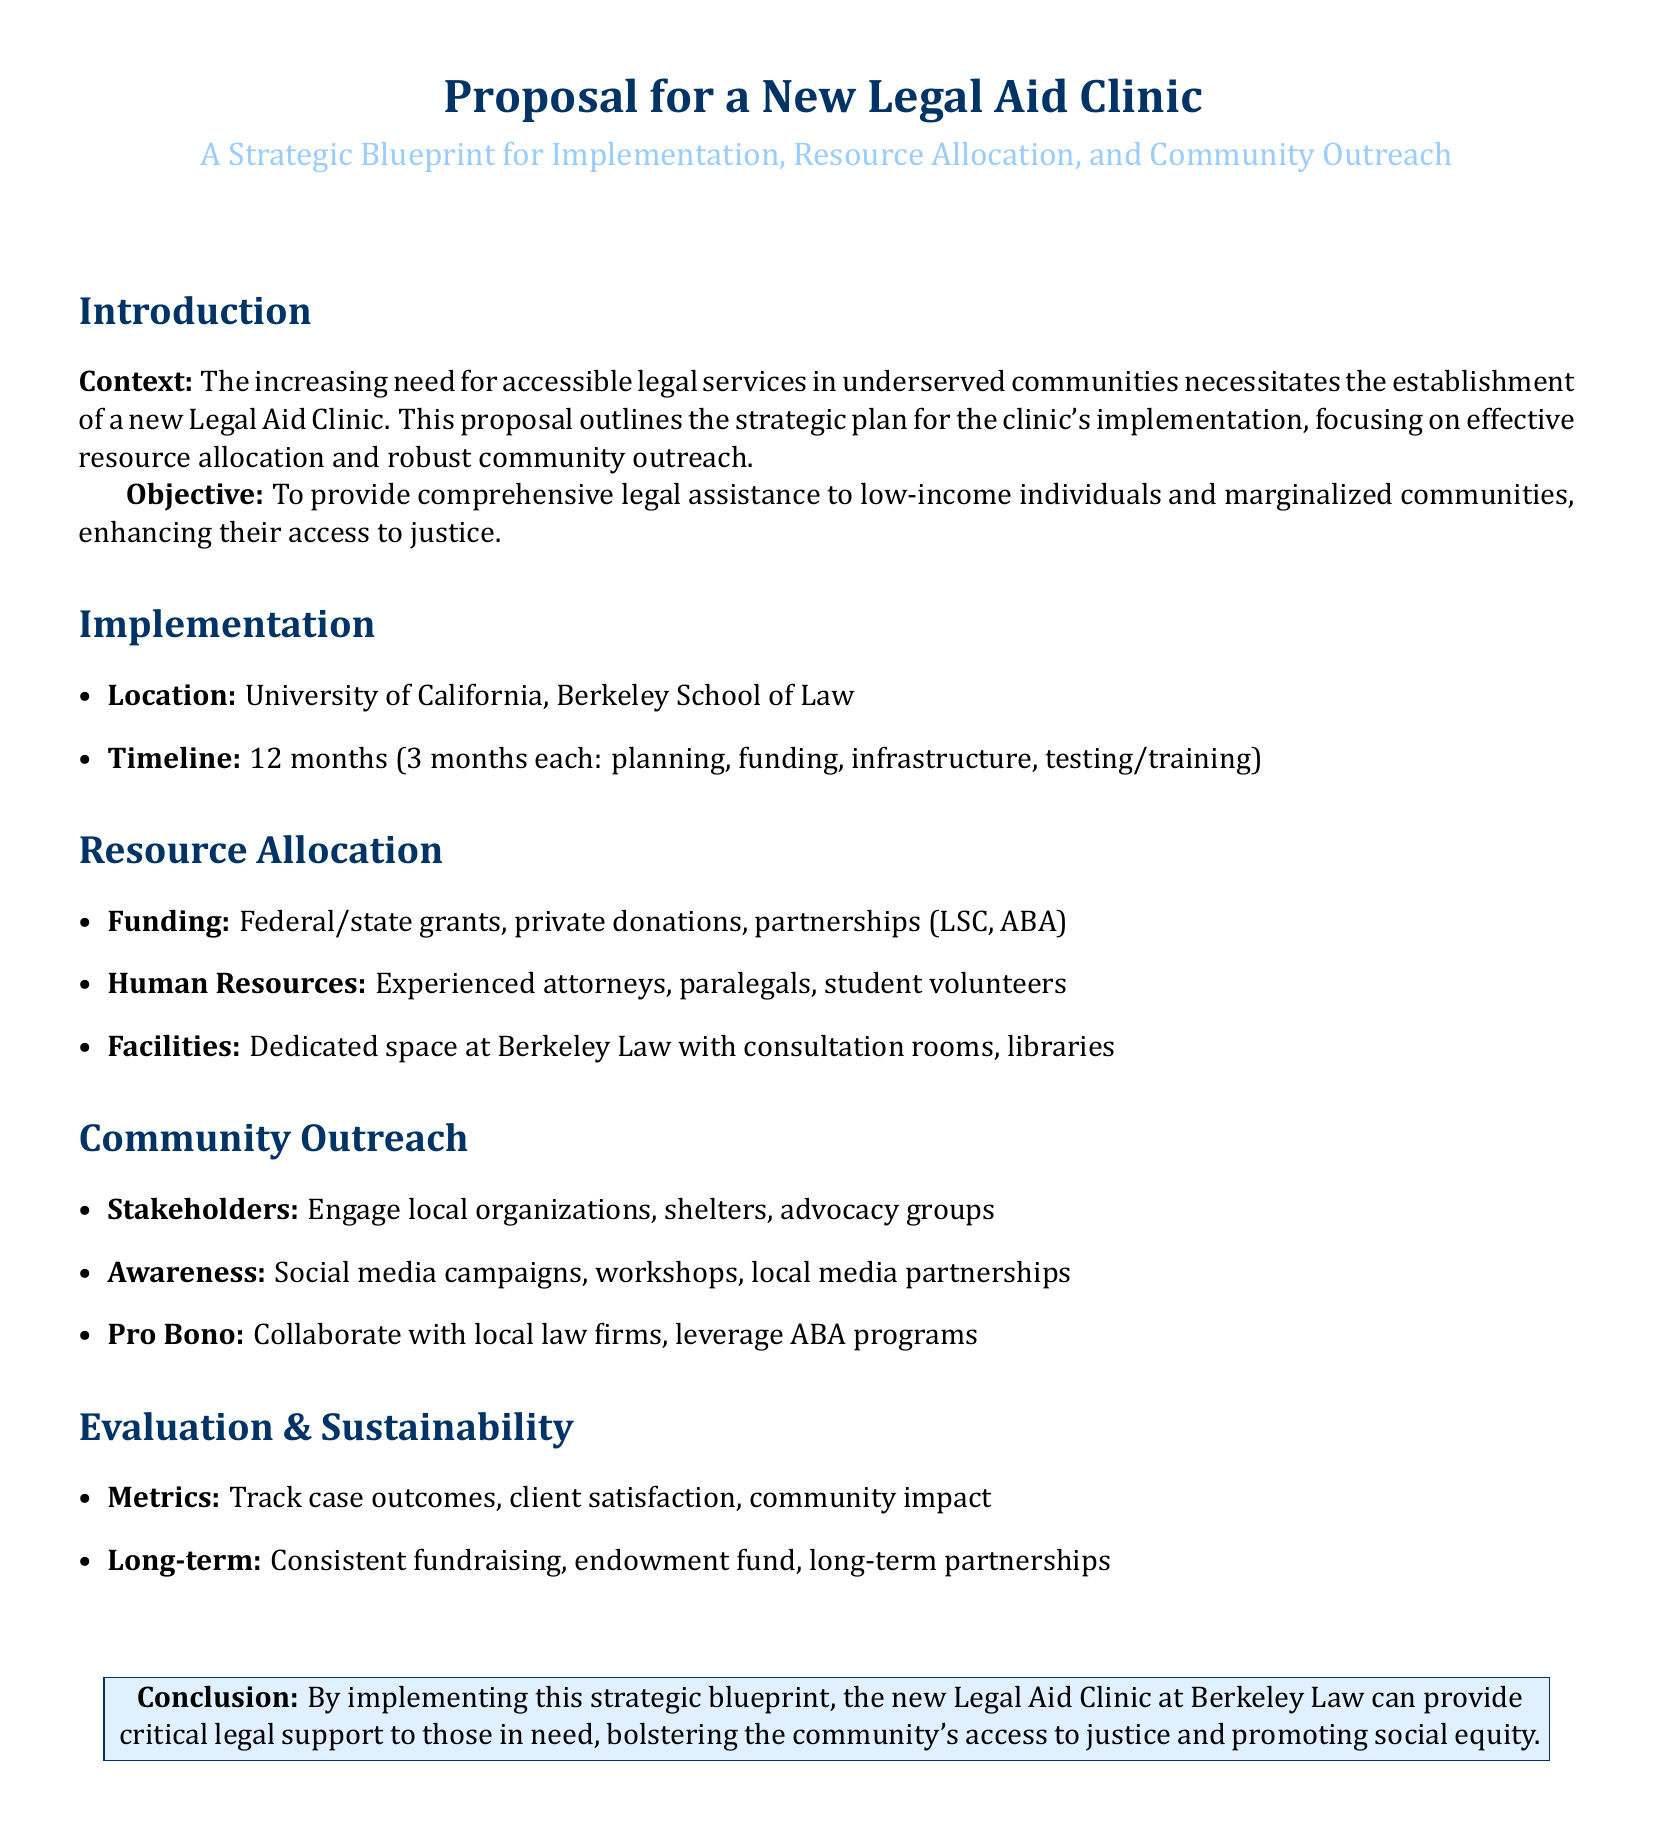What is the main objective of the proposal? The main objective outlined in the proposal is to provide comprehensive legal assistance to low-income individuals and marginalized communities, enhancing their access to justice.
Answer: To provide comprehensive legal assistance What is the planned duration for the clinic's implementation? The proposal states that the timeline for implementation is 12 months, divided across different phases.
Answer: 12 months Where will the Legal Aid Clinic be located? The document specifies that the clinic will be located at the University of California, Berkeley School of Law.
Answer: University of California, Berkeley School of Law Who are the key human resources mentioned for the clinic? The proposal lists experienced attorneys, paralegals, and student volunteers as essential human resources for the clinic.
Answer: Experienced attorneys, paralegals, student volunteers What are the two primary funding sources identified for the clinic? The document identifies federal/state grants and private donations as primary funding sources for the new clinic.
Answer: Federal/state grants, private donations What type of outreach method is proposed to engage the community? The proposal suggests using social media campaigns as one of the methods for community outreach.
Answer: Social media campaigns Which local entities are mentioned as stakeholders for community engagement? The document refers to local organizations, shelters, and advocacy groups as stakeholders to engage with.
Answer: Local organizations, shelters, advocacy groups What metrics will be used to evaluate the clinic's effectiveness? The document mentions tracking case outcomes, client satisfaction, and community impact as metrics for evaluation.
Answer: Case outcomes, client satisfaction, community impact What is the proposed long-term strategy for the clinic's sustainability? The proposal emphasizes consistent fundraising and the establishment of an endowment fund as long-term strategies for sustainability.
Answer: Consistent fundraising, endowment fund 